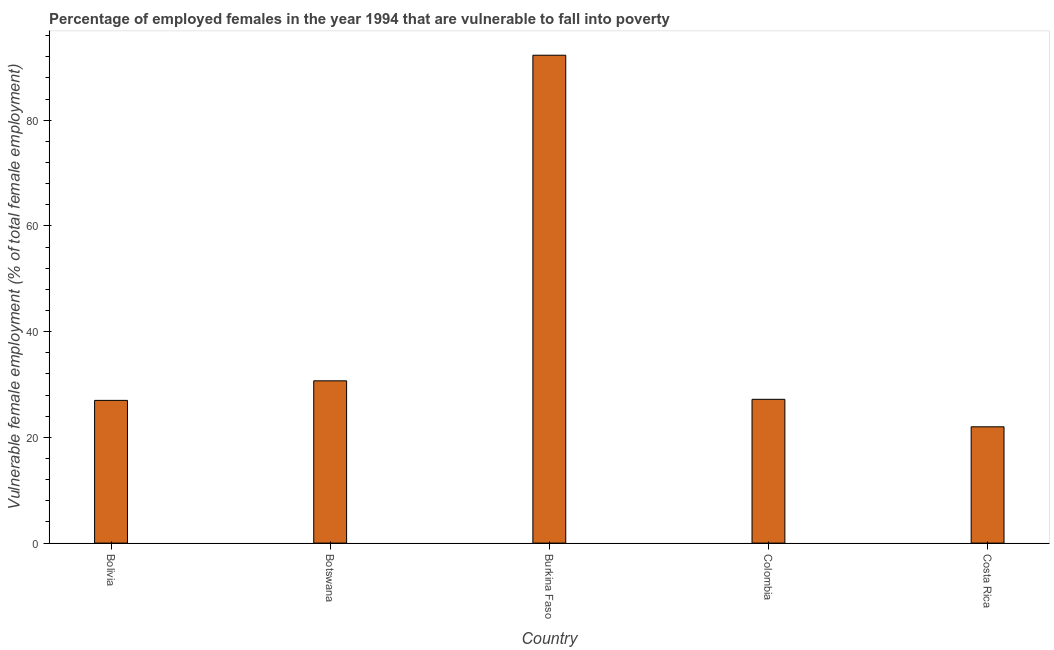Does the graph contain grids?
Ensure brevity in your answer.  No. What is the title of the graph?
Give a very brief answer. Percentage of employed females in the year 1994 that are vulnerable to fall into poverty. What is the label or title of the X-axis?
Your answer should be very brief. Country. What is the label or title of the Y-axis?
Keep it short and to the point. Vulnerable female employment (% of total female employment). What is the percentage of employed females who are vulnerable to fall into poverty in Botswana?
Your answer should be compact. 30.7. Across all countries, what is the maximum percentage of employed females who are vulnerable to fall into poverty?
Your response must be concise. 92.3. In which country was the percentage of employed females who are vulnerable to fall into poverty maximum?
Provide a short and direct response. Burkina Faso. In which country was the percentage of employed females who are vulnerable to fall into poverty minimum?
Give a very brief answer. Costa Rica. What is the sum of the percentage of employed females who are vulnerable to fall into poverty?
Give a very brief answer. 199.2. What is the average percentage of employed females who are vulnerable to fall into poverty per country?
Give a very brief answer. 39.84. What is the median percentage of employed females who are vulnerable to fall into poverty?
Provide a succinct answer. 27.2. In how many countries, is the percentage of employed females who are vulnerable to fall into poverty greater than 80 %?
Provide a short and direct response. 1. What is the ratio of the percentage of employed females who are vulnerable to fall into poverty in Bolivia to that in Costa Rica?
Ensure brevity in your answer.  1.23. Is the percentage of employed females who are vulnerable to fall into poverty in Burkina Faso less than that in Costa Rica?
Your response must be concise. No. What is the difference between the highest and the second highest percentage of employed females who are vulnerable to fall into poverty?
Give a very brief answer. 61.6. What is the difference between the highest and the lowest percentage of employed females who are vulnerable to fall into poverty?
Provide a succinct answer. 70.3. Are all the bars in the graph horizontal?
Offer a terse response. No. How many countries are there in the graph?
Your answer should be very brief. 5. What is the difference between two consecutive major ticks on the Y-axis?
Your answer should be very brief. 20. What is the Vulnerable female employment (% of total female employment) in Botswana?
Make the answer very short. 30.7. What is the Vulnerable female employment (% of total female employment) of Burkina Faso?
Provide a succinct answer. 92.3. What is the Vulnerable female employment (% of total female employment) of Colombia?
Give a very brief answer. 27.2. What is the difference between the Vulnerable female employment (% of total female employment) in Bolivia and Botswana?
Provide a succinct answer. -3.7. What is the difference between the Vulnerable female employment (% of total female employment) in Bolivia and Burkina Faso?
Offer a terse response. -65.3. What is the difference between the Vulnerable female employment (% of total female employment) in Bolivia and Colombia?
Offer a terse response. -0.2. What is the difference between the Vulnerable female employment (% of total female employment) in Bolivia and Costa Rica?
Your response must be concise. 5. What is the difference between the Vulnerable female employment (% of total female employment) in Botswana and Burkina Faso?
Give a very brief answer. -61.6. What is the difference between the Vulnerable female employment (% of total female employment) in Botswana and Costa Rica?
Ensure brevity in your answer.  8.7. What is the difference between the Vulnerable female employment (% of total female employment) in Burkina Faso and Colombia?
Give a very brief answer. 65.1. What is the difference between the Vulnerable female employment (% of total female employment) in Burkina Faso and Costa Rica?
Offer a terse response. 70.3. What is the difference between the Vulnerable female employment (% of total female employment) in Colombia and Costa Rica?
Offer a very short reply. 5.2. What is the ratio of the Vulnerable female employment (% of total female employment) in Bolivia to that in Botswana?
Offer a very short reply. 0.88. What is the ratio of the Vulnerable female employment (% of total female employment) in Bolivia to that in Burkina Faso?
Provide a short and direct response. 0.29. What is the ratio of the Vulnerable female employment (% of total female employment) in Bolivia to that in Colombia?
Offer a very short reply. 0.99. What is the ratio of the Vulnerable female employment (% of total female employment) in Bolivia to that in Costa Rica?
Provide a short and direct response. 1.23. What is the ratio of the Vulnerable female employment (% of total female employment) in Botswana to that in Burkina Faso?
Make the answer very short. 0.33. What is the ratio of the Vulnerable female employment (% of total female employment) in Botswana to that in Colombia?
Your answer should be very brief. 1.13. What is the ratio of the Vulnerable female employment (% of total female employment) in Botswana to that in Costa Rica?
Your response must be concise. 1.4. What is the ratio of the Vulnerable female employment (% of total female employment) in Burkina Faso to that in Colombia?
Provide a short and direct response. 3.39. What is the ratio of the Vulnerable female employment (% of total female employment) in Burkina Faso to that in Costa Rica?
Your response must be concise. 4.2. What is the ratio of the Vulnerable female employment (% of total female employment) in Colombia to that in Costa Rica?
Offer a terse response. 1.24. 